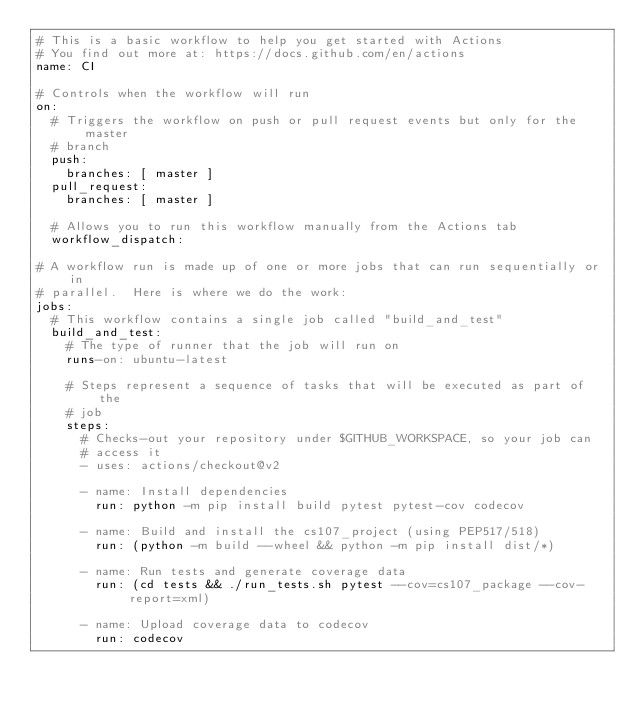Convert code to text. <code><loc_0><loc_0><loc_500><loc_500><_YAML_># This is a basic workflow to help you get started with Actions
# You find out more at: https://docs.github.com/en/actions
name: CI

# Controls when the workflow will run
on:
  # Triggers the workflow on push or pull request events but only for the master
  # branch
  push:
    branches: [ master ]
  pull_request:
    branches: [ master ]

  # Allows you to run this workflow manually from the Actions tab
  workflow_dispatch:

# A workflow run is made up of one or more jobs that can run sequentially or in
# parallel.  Here is where we do the work:
jobs:
  # This workflow contains a single job called "build_and_test"
  build_and_test:
    # The type of runner that the job will run on
    runs-on: ubuntu-latest

    # Steps represent a sequence of tasks that will be executed as part of the
    # job
    steps:
      # Checks-out your repository under $GITHUB_WORKSPACE, so your job can
      # access it
      - uses: actions/checkout@v2

      - name: Install dependencies
        run: python -m pip install build pytest pytest-cov codecov

      - name: Build and install the cs107_project (using PEP517/518)
        run: (python -m build --wheel && python -m pip install dist/*)

      - name: Run tests and generate coverage data
        run: (cd tests && ./run_tests.sh pytest --cov=cs107_package --cov-report=xml)

      - name: Upload coverage data to codecov
        run: codecov
</code> 